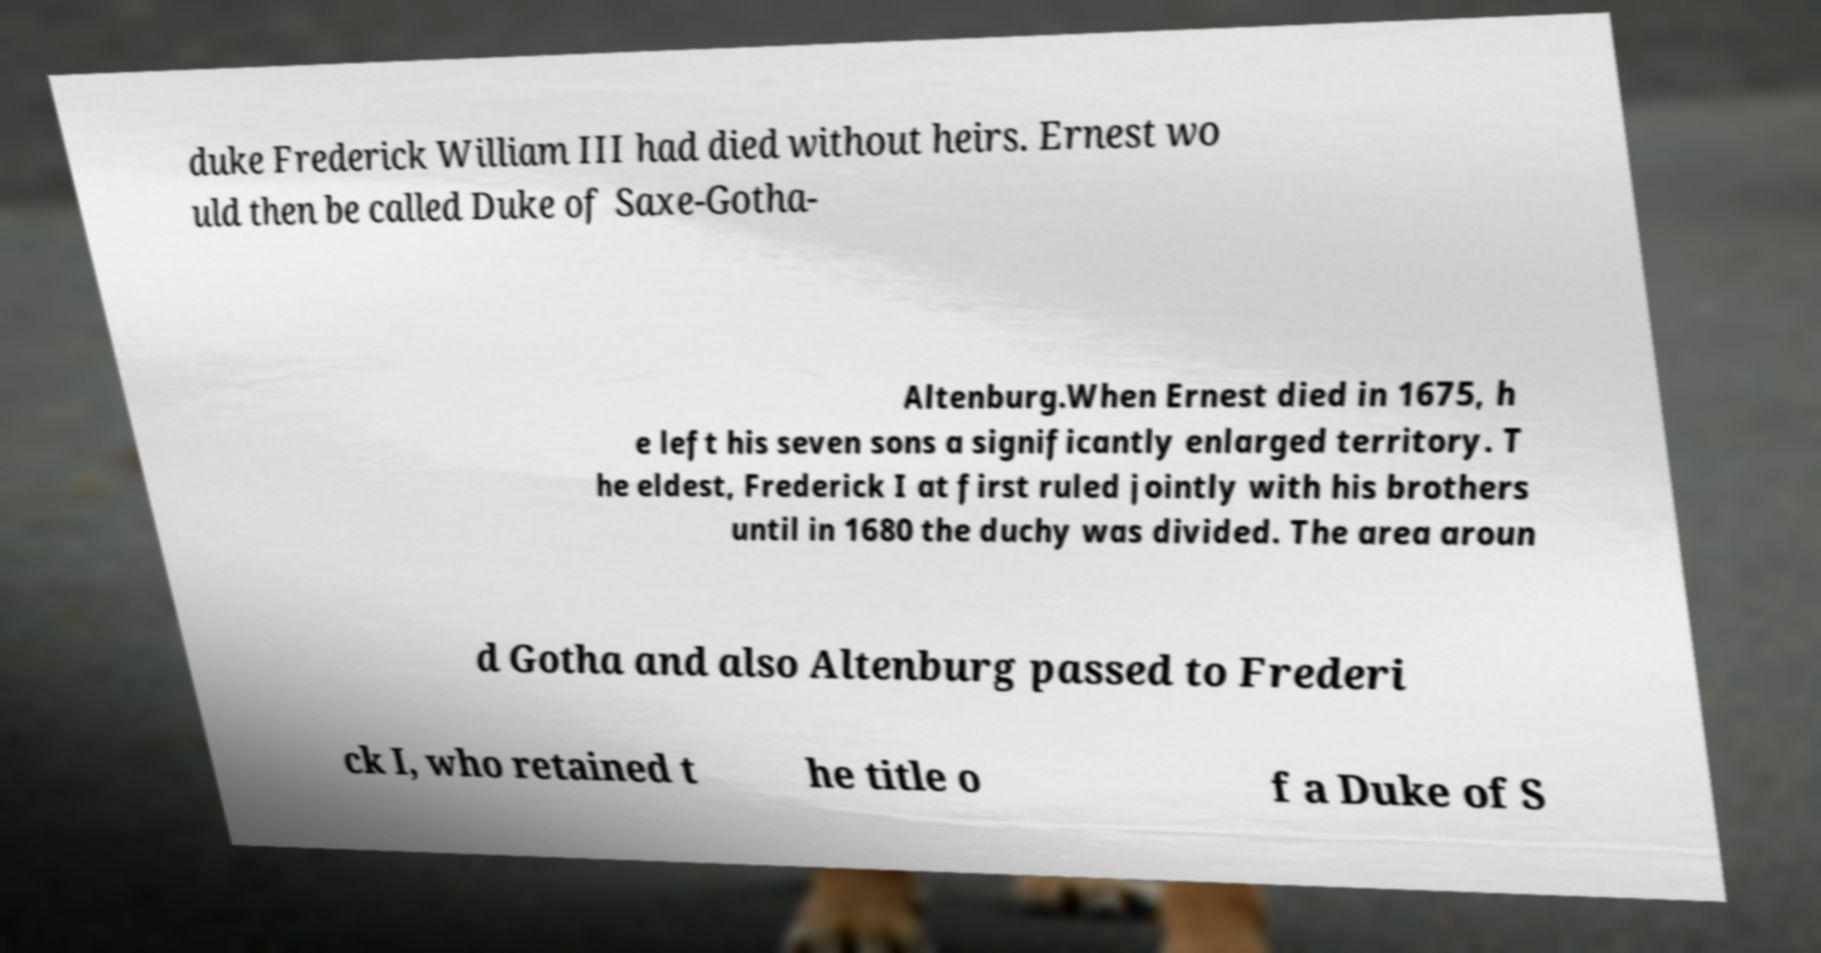There's text embedded in this image that I need extracted. Can you transcribe it verbatim? duke Frederick William III had died without heirs. Ernest wo uld then be called Duke of Saxe-Gotha- Altenburg.When Ernest died in 1675, h e left his seven sons a significantly enlarged territory. T he eldest, Frederick I at first ruled jointly with his brothers until in 1680 the duchy was divided. The area aroun d Gotha and also Altenburg passed to Frederi ck I, who retained t he title o f a Duke of S 